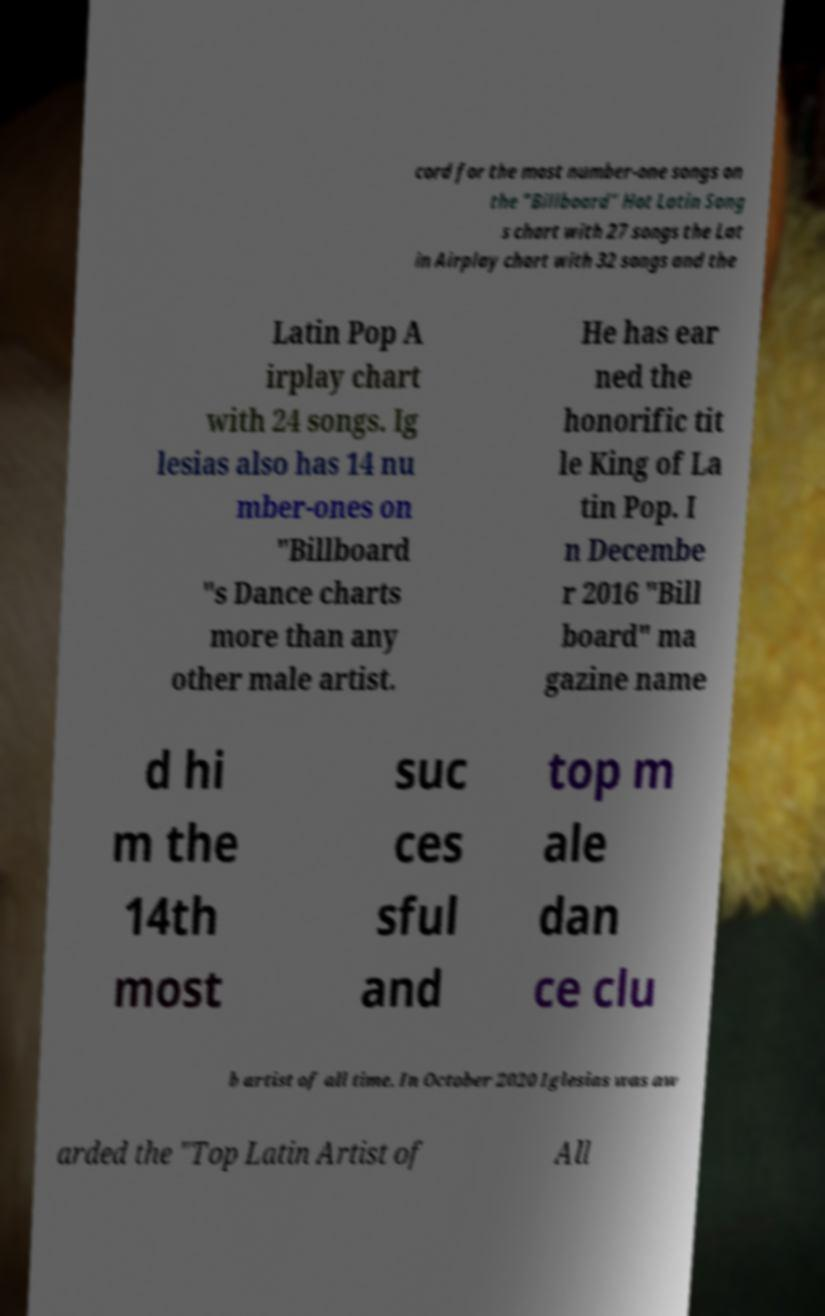Could you extract and type out the text from this image? cord for the most number-one songs on the "Billboard" Hot Latin Song s chart with 27 songs the Lat in Airplay chart with 32 songs and the Latin Pop A irplay chart with 24 songs. Ig lesias also has 14 nu mber-ones on "Billboard "s Dance charts more than any other male artist. He has ear ned the honorific tit le King of La tin Pop. I n Decembe r 2016 "Bill board" ma gazine name d hi m the 14th most suc ces sful and top m ale dan ce clu b artist of all time. In October 2020 Iglesias was aw arded the "Top Latin Artist of All 